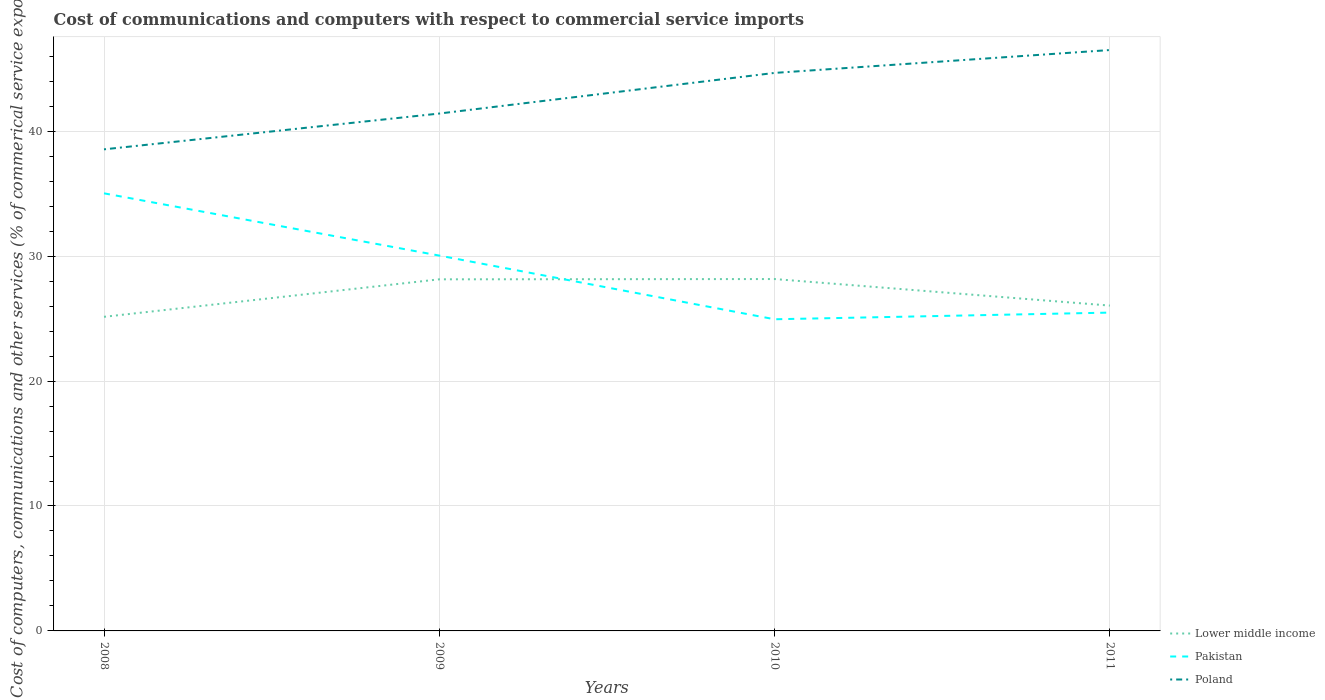How many different coloured lines are there?
Give a very brief answer. 3. Across all years, what is the maximum cost of communications and computers in Lower middle income?
Offer a terse response. 25.14. In which year was the cost of communications and computers in Poland maximum?
Provide a succinct answer. 2008. What is the total cost of communications and computers in Poland in the graph?
Your answer should be very brief. -5.08. What is the difference between the highest and the second highest cost of communications and computers in Lower middle income?
Provide a succinct answer. 3.02. What is the difference between the highest and the lowest cost of communications and computers in Pakistan?
Your answer should be compact. 2. How many lines are there?
Ensure brevity in your answer.  3. How many years are there in the graph?
Your answer should be very brief. 4. What is the difference between two consecutive major ticks on the Y-axis?
Your answer should be very brief. 10. Are the values on the major ticks of Y-axis written in scientific E-notation?
Provide a short and direct response. No. Does the graph contain any zero values?
Your answer should be compact. No. How many legend labels are there?
Give a very brief answer. 3. What is the title of the graph?
Keep it short and to the point. Cost of communications and computers with respect to commercial service imports. What is the label or title of the X-axis?
Give a very brief answer. Years. What is the label or title of the Y-axis?
Make the answer very short. Cost of computers, communications and other services (% of commerical service exports). What is the Cost of computers, communications and other services (% of commerical service exports) in Lower middle income in 2008?
Ensure brevity in your answer.  25.14. What is the Cost of computers, communications and other services (% of commerical service exports) of Pakistan in 2008?
Keep it short and to the point. 35.03. What is the Cost of computers, communications and other services (% of commerical service exports) of Poland in 2008?
Your response must be concise. 38.55. What is the Cost of computers, communications and other services (% of commerical service exports) in Lower middle income in 2009?
Your answer should be compact. 28.14. What is the Cost of computers, communications and other services (% of commerical service exports) in Pakistan in 2009?
Your answer should be compact. 30.04. What is the Cost of computers, communications and other services (% of commerical service exports) in Poland in 2009?
Your answer should be compact. 41.41. What is the Cost of computers, communications and other services (% of commerical service exports) of Lower middle income in 2010?
Provide a succinct answer. 28.17. What is the Cost of computers, communications and other services (% of commerical service exports) of Pakistan in 2010?
Provide a short and direct response. 24.95. What is the Cost of computers, communications and other services (% of commerical service exports) in Poland in 2010?
Give a very brief answer. 44.67. What is the Cost of computers, communications and other services (% of commerical service exports) in Lower middle income in 2011?
Make the answer very short. 26.04. What is the Cost of computers, communications and other services (% of commerical service exports) of Pakistan in 2011?
Your response must be concise. 25.48. What is the Cost of computers, communications and other services (% of commerical service exports) of Poland in 2011?
Give a very brief answer. 46.5. Across all years, what is the maximum Cost of computers, communications and other services (% of commerical service exports) in Lower middle income?
Give a very brief answer. 28.17. Across all years, what is the maximum Cost of computers, communications and other services (% of commerical service exports) of Pakistan?
Your response must be concise. 35.03. Across all years, what is the maximum Cost of computers, communications and other services (% of commerical service exports) of Poland?
Provide a short and direct response. 46.5. Across all years, what is the minimum Cost of computers, communications and other services (% of commerical service exports) of Lower middle income?
Keep it short and to the point. 25.14. Across all years, what is the minimum Cost of computers, communications and other services (% of commerical service exports) in Pakistan?
Give a very brief answer. 24.95. Across all years, what is the minimum Cost of computers, communications and other services (% of commerical service exports) of Poland?
Offer a very short reply. 38.55. What is the total Cost of computers, communications and other services (% of commerical service exports) in Lower middle income in the graph?
Provide a succinct answer. 107.5. What is the total Cost of computers, communications and other services (% of commerical service exports) in Pakistan in the graph?
Ensure brevity in your answer.  115.5. What is the total Cost of computers, communications and other services (% of commerical service exports) in Poland in the graph?
Keep it short and to the point. 171.13. What is the difference between the Cost of computers, communications and other services (% of commerical service exports) in Lower middle income in 2008 and that in 2009?
Keep it short and to the point. -3. What is the difference between the Cost of computers, communications and other services (% of commerical service exports) in Pakistan in 2008 and that in 2009?
Give a very brief answer. 4.98. What is the difference between the Cost of computers, communications and other services (% of commerical service exports) of Poland in 2008 and that in 2009?
Provide a succinct answer. -2.87. What is the difference between the Cost of computers, communications and other services (% of commerical service exports) in Lower middle income in 2008 and that in 2010?
Your response must be concise. -3.02. What is the difference between the Cost of computers, communications and other services (% of commerical service exports) of Pakistan in 2008 and that in 2010?
Your answer should be very brief. 10.08. What is the difference between the Cost of computers, communications and other services (% of commerical service exports) in Poland in 2008 and that in 2010?
Your answer should be very brief. -6.12. What is the difference between the Cost of computers, communications and other services (% of commerical service exports) in Lower middle income in 2008 and that in 2011?
Provide a succinct answer. -0.9. What is the difference between the Cost of computers, communications and other services (% of commerical service exports) of Pakistan in 2008 and that in 2011?
Your answer should be very brief. 9.55. What is the difference between the Cost of computers, communications and other services (% of commerical service exports) of Poland in 2008 and that in 2011?
Ensure brevity in your answer.  -7.95. What is the difference between the Cost of computers, communications and other services (% of commerical service exports) of Lower middle income in 2009 and that in 2010?
Your answer should be very brief. -0.02. What is the difference between the Cost of computers, communications and other services (% of commerical service exports) of Pakistan in 2009 and that in 2010?
Offer a very short reply. 5.1. What is the difference between the Cost of computers, communications and other services (% of commerical service exports) in Poland in 2009 and that in 2010?
Keep it short and to the point. -3.25. What is the difference between the Cost of computers, communications and other services (% of commerical service exports) in Lower middle income in 2009 and that in 2011?
Provide a short and direct response. 2.1. What is the difference between the Cost of computers, communications and other services (% of commerical service exports) of Pakistan in 2009 and that in 2011?
Your answer should be compact. 4.56. What is the difference between the Cost of computers, communications and other services (% of commerical service exports) of Poland in 2009 and that in 2011?
Offer a terse response. -5.08. What is the difference between the Cost of computers, communications and other services (% of commerical service exports) of Lower middle income in 2010 and that in 2011?
Offer a very short reply. 2.12. What is the difference between the Cost of computers, communications and other services (% of commerical service exports) in Pakistan in 2010 and that in 2011?
Keep it short and to the point. -0.53. What is the difference between the Cost of computers, communications and other services (% of commerical service exports) in Poland in 2010 and that in 2011?
Offer a terse response. -1.83. What is the difference between the Cost of computers, communications and other services (% of commerical service exports) of Lower middle income in 2008 and the Cost of computers, communications and other services (% of commerical service exports) of Pakistan in 2009?
Provide a short and direct response. -4.9. What is the difference between the Cost of computers, communications and other services (% of commerical service exports) of Lower middle income in 2008 and the Cost of computers, communications and other services (% of commerical service exports) of Poland in 2009?
Offer a very short reply. -16.27. What is the difference between the Cost of computers, communications and other services (% of commerical service exports) of Pakistan in 2008 and the Cost of computers, communications and other services (% of commerical service exports) of Poland in 2009?
Offer a terse response. -6.39. What is the difference between the Cost of computers, communications and other services (% of commerical service exports) of Lower middle income in 2008 and the Cost of computers, communications and other services (% of commerical service exports) of Pakistan in 2010?
Offer a terse response. 0.2. What is the difference between the Cost of computers, communications and other services (% of commerical service exports) of Lower middle income in 2008 and the Cost of computers, communications and other services (% of commerical service exports) of Poland in 2010?
Offer a very short reply. -19.52. What is the difference between the Cost of computers, communications and other services (% of commerical service exports) in Pakistan in 2008 and the Cost of computers, communications and other services (% of commerical service exports) in Poland in 2010?
Ensure brevity in your answer.  -9.64. What is the difference between the Cost of computers, communications and other services (% of commerical service exports) of Lower middle income in 2008 and the Cost of computers, communications and other services (% of commerical service exports) of Pakistan in 2011?
Offer a terse response. -0.34. What is the difference between the Cost of computers, communications and other services (% of commerical service exports) in Lower middle income in 2008 and the Cost of computers, communications and other services (% of commerical service exports) in Poland in 2011?
Keep it short and to the point. -21.35. What is the difference between the Cost of computers, communications and other services (% of commerical service exports) in Pakistan in 2008 and the Cost of computers, communications and other services (% of commerical service exports) in Poland in 2011?
Your answer should be compact. -11.47. What is the difference between the Cost of computers, communications and other services (% of commerical service exports) of Lower middle income in 2009 and the Cost of computers, communications and other services (% of commerical service exports) of Pakistan in 2010?
Your answer should be very brief. 3.2. What is the difference between the Cost of computers, communications and other services (% of commerical service exports) in Lower middle income in 2009 and the Cost of computers, communications and other services (% of commerical service exports) in Poland in 2010?
Provide a short and direct response. -16.52. What is the difference between the Cost of computers, communications and other services (% of commerical service exports) of Pakistan in 2009 and the Cost of computers, communications and other services (% of commerical service exports) of Poland in 2010?
Offer a terse response. -14.62. What is the difference between the Cost of computers, communications and other services (% of commerical service exports) in Lower middle income in 2009 and the Cost of computers, communications and other services (% of commerical service exports) in Pakistan in 2011?
Give a very brief answer. 2.66. What is the difference between the Cost of computers, communications and other services (% of commerical service exports) of Lower middle income in 2009 and the Cost of computers, communications and other services (% of commerical service exports) of Poland in 2011?
Your response must be concise. -18.35. What is the difference between the Cost of computers, communications and other services (% of commerical service exports) in Pakistan in 2009 and the Cost of computers, communications and other services (% of commerical service exports) in Poland in 2011?
Your answer should be very brief. -16.45. What is the difference between the Cost of computers, communications and other services (% of commerical service exports) in Lower middle income in 2010 and the Cost of computers, communications and other services (% of commerical service exports) in Pakistan in 2011?
Your answer should be compact. 2.69. What is the difference between the Cost of computers, communications and other services (% of commerical service exports) in Lower middle income in 2010 and the Cost of computers, communications and other services (% of commerical service exports) in Poland in 2011?
Your answer should be very brief. -18.33. What is the difference between the Cost of computers, communications and other services (% of commerical service exports) in Pakistan in 2010 and the Cost of computers, communications and other services (% of commerical service exports) in Poland in 2011?
Your answer should be compact. -21.55. What is the average Cost of computers, communications and other services (% of commerical service exports) of Lower middle income per year?
Provide a short and direct response. 26.87. What is the average Cost of computers, communications and other services (% of commerical service exports) in Pakistan per year?
Your answer should be very brief. 28.87. What is the average Cost of computers, communications and other services (% of commerical service exports) in Poland per year?
Provide a succinct answer. 42.78. In the year 2008, what is the difference between the Cost of computers, communications and other services (% of commerical service exports) of Lower middle income and Cost of computers, communications and other services (% of commerical service exports) of Pakistan?
Offer a terse response. -9.88. In the year 2008, what is the difference between the Cost of computers, communications and other services (% of commerical service exports) of Lower middle income and Cost of computers, communications and other services (% of commerical service exports) of Poland?
Give a very brief answer. -13.4. In the year 2008, what is the difference between the Cost of computers, communications and other services (% of commerical service exports) of Pakistan and Cost of computers, communications and other services (% of commerical service exports) of Poland?
Your answer should be compact. -3.52. In the year 2009, what is the difference between the Cost of computers, communications and other services (% of commerical service exports) of Lower middle income and Cost of computers, communications and other services (% of commerical service exports) of Pakistan?
Offer a terse response. -1.9. In the year 2009, what is the difference between the Cost of computers, communications and other services (% of commerical service exports) of Lower middle income and Cost of computers, communications and other services (% of commerical service exports) of Poland?
Provide a short and direct response. -13.27. In the year 2009, what is the difference between the Cost of computers, communications and other services (% of commerical service exports) of Pakistan and Cost of computers, communications and other services (% of commerical service exports) of Poland?
Make the answer very short. -11.37. In the year 2010, what is the difference between the Cost of computers, communications and other services (% of commerical service exports) of Lower middle income and Cost of computers, communications and other services (% of commerical service exports) of Pakistan?
Your answer should be very brief. 3.22. In the year 2010, what is the difference between the Cost of computers, communications and other services (% of commerical service exports) in Lower middle income and Cost of computers, communications and other services (% of commerical service exports) in Poland?
Make the answer very short. -16.5. In the year 2010, what is the difference between the Cost of computers, communications and other services (% of commerical service exports) of Pakistan and Cost of computers, communications and other services (% of commerical service exports) of Poland?
Your answer should be very brief. -19.72. In the year 2011, what is the difference between the Cost of computers, communications and other services (% of commerical service exports) of Lower middle income and Cost of computers, communications and other services (% of commerical service exports) of Pakistan?
Your response must be concise. 0.56. In the year 2011, what is the difference between the Cost of computers, communications and other services (% of commerical service exports) in Lower middle income and Cost of computers, communications and other services (% of commerical service exports) in Poland?
Your answer should be compact. -20.46. In the year 2011, what is the difference between the Cost of computers, communications and other services (% of commerical service exports) of Pakistan and Cost of computers, communications and other services (% of commerical service exports) of Poland?
Offer a terse response. -21.02. What is the ratio of the Cost of computers, communications and other services (% of commerical service exports) of Lower middle income in 2008 to that in 2009?
Provide a succinct answer. 0.89. What is the ratio of the Cost of computers, communications and other services (% of commerical service exports) of Pakistan in 2008 to that in 2009?
Offer a very short reply. 1.17. What is the ratio of the Cost of computers, communications and other services (% of commerical service exports) of Poland in 2008 to that in 2009?
Provide a short and direct response. 0.93. What is the ratio of the Cost of computers, communications and other services (% of commerical service exports) of Lower middle income in 2008 to that in 2010?
Offer a terse response. 0.89. What is the ratio of the Cost of computers, communications and other services (% of commerical service exports) in Pakistan in 2008 to that in 2010?
Give a very brief answer. 1.4. What is the ratio of the Cost of computers, communications and other services (% of commerical service exports) in Poland in 2008 to that in 2010?
Provide a succinct answer. 0.86. What is the ratio of the Cost of computers, communications and other services (% of commerical service exports) in Lower middle income in 2008 to that in 2011?
Give a very brief answer. 0.97. What is the ratio of the Cost of computers, communications and other services (% of commerical service exports) in Pakistan in 2008 to that in 2011?
Provide a succinct answer. 1.37. What is the ratio of the Cost of computers, communications and other services (% of commerical service exports) of Poland in 2008 to that in 2011?
Offer a very short reply. 0.83. What is the ratio of the Cost of computers, communications and other services (% of commerical service exports) in Pakistan in 2009 to that in 2010?
Offer a terse response. 1.2. What is the ratio of the Cost of computers, communications and other services (% of commerical service exports) of Poland in 2009 to that in 2010?
Your answer should be very brief. 0.93. What is the ratio of the Cost of computers, communications and other services (% of commerical service exports) in Lower middle income in 2009 to that in 2011?
Keep it short and to the point. 1.08. What is the ratio of the Cost of computers, communications and other services (% of commerical service exports) in Pakistan in 2009 to that in 2011?
Your answer should be very brief. 1.18. What is the ratio of the Cost of computers, communications and other services (% of commerical service exports) in Poland in 2009 to that in 2011?
Ensure brevity in your answer.  0.89. What is the ratio of the Cost of computers, communications and other services (% of commerical service exports) of Lower middle income in 2010 to that in 2011?
Your response must be concise. 1.08. What is the ratio of the Cost of computers, communications and other services (% of commerical service exports) of Poland in 2010 to that in 2011?
Your response must be concise. 0.96. What is the difference between the highest and the second highest Cost of computers, communications and other services (% of commerical service exports) of Lower middle income?
Provide a succinct answer. 0.02. What is the difference between the highest and the second highest Cost of computers, communications and other services (% of commerical service exports) of Pakistan?
Make the answer very short. 4.98. What is the difference between the highest and the second highest Cost of computers, communications and other services (% of commerical service exports) in Poland?
Offer a terse response. 1.83. What is the difference between the highest and the lowest Cost of computers, communications and other services (% of commerical service exports) in Lower middle income?
Keep it short and to the point. 3.02. What is the difference between the highest and the lowest Cost of computers, communications and other services (% of commerical service exports) of Pakistan?
Make the answer very short. 10.08. What is the difference between the highest and the lowest Cost of computers, communications and other services (% of commerical service exports) of Poland?
Your response must be concise. 7.95. 